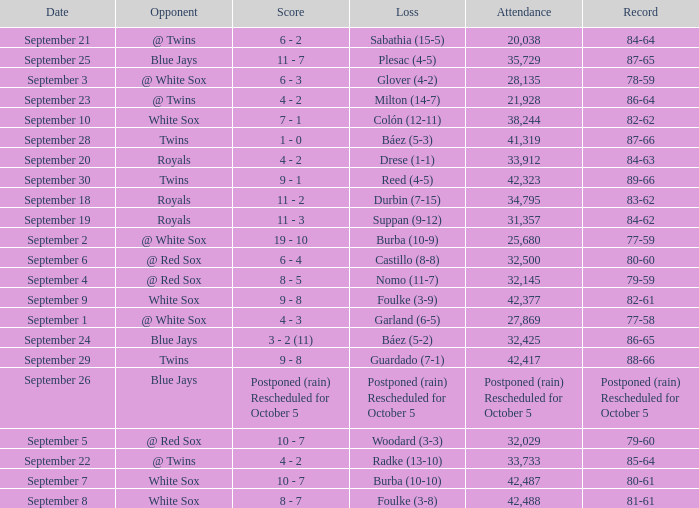I'm looking to parse the entire table for insights. Could you assist me with that? {'header': ['Date', 'Opponent', 'Score', 'Loss', 'Attendance', 'Record'], 'rows': [['September 21', '@ Twins', '6 - 2', 'Sabathia (15-5)', '20,038', '84-64'], ['September 25', 'Blue Jays', '11 - 7', 'Plesac (4-5)', '35,729', '87-65'], ['September 3', '@ White Sox', '6 - 3', 'Glover (4-2)', '28,135', '78-59'], ['September 23', '@ Twins', '4 - 2', 'Milton (14-7)', '21,928', '86-64'], ['September 10', 'White Sox', '7 - 1', 'Colón (12-11)', '38,244', '82-62'], ['September 28', 'Twins', '1 - 0', 'Báez (5-3)', '41,319', '87-66'], ['September 20', 'Royals', '4 - 2', 'Drese (1-1)', '33,912', '84-63'], ['September 30', 'Twins', '9 - 1', 'Reed (4-5)', '42,323', '89-66'], ['September 18', 'Royals', '11 - 2', 'Durbin (7-15)', '34,795', '83-62'], ['September 19', 'Royals', '11 - 3', 'Suppan (9-12)', '31,357', '84-62'], ['September 2', '@ White Sox', '19 - 10', 'Burba (10-9)', '25,680', '77-59'], ['September 6', '@ Red Sox', '6 - 4', 'Castillo (8-8)', '32,500', '80-60'], ['September 4', '@ Red Sox', '8 - 5', 'Nomo (11-7)', '32,145', '79-59'], ['September 9', 'White Sox', '9 - 8', 'Foulke (3-9)', '42,377', '82-61'], ['September 1', '@ White Sox', '4 - 3', 'Garland (6-5)', '27,869', '77-58'], ['September 24', 'Blue Jays', '3 - 2 (11)', 'Báez (5-2)', '32,425', '86-65'], ['September 29', 'Twins', '9 - 8', 'Guardado (7-1)', '42,417', '88-66'], ['September 26', 'Blue Jays', 'Postponed (rain) Rescheduled for October 5', 'Postponed (rain) Rescheduled for October 5', 'Postponed (rain) Rescheduled for October 5', 'Postponed (rain) Rescheduled for October 5'], ['September 5', '@ Red Sox', '10 - 7', 'Woodard (3-3)', '32,029', '79-60'], ['September 22', '@ Twins', '4 - 2', 'Radke (13-10)', '33,733', '85-64'], ['September 7', 'White Sox', '10 - 7', 'Burba (10-10)', '42,487', '80-61'], ['September 8', 'White Sox', '8 - 7', 'Foulke (3-8)', '42,488', '81-61']]} What is the score of the game that holds a record of 80-61? 10 - 7. 